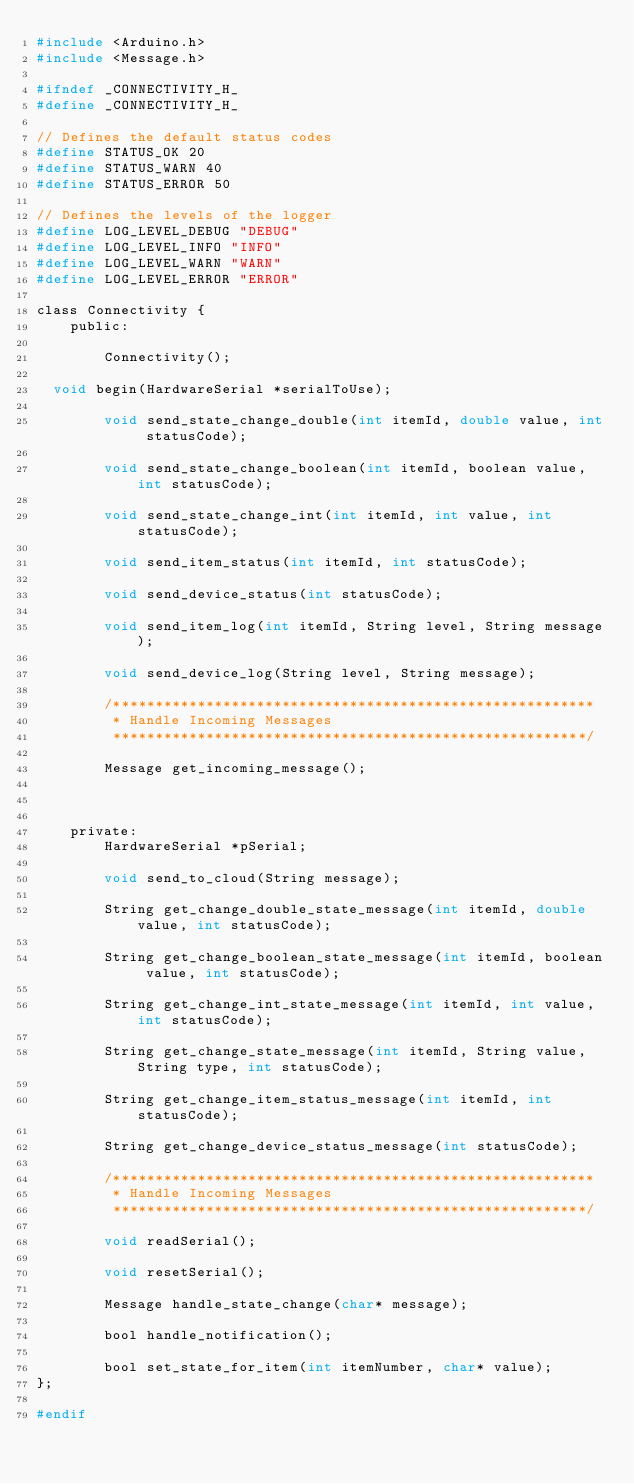<code> <loc_0><loc_0><loc_500><loc_500><_C_>#include <Arduino.h>
#include <Message.h>

#ifndef _CONNECTIVITY_H_
#define _CONNECTIVITY_H_

// Defines the default status codes
#define STATUS_OK 20
#define STATUS_WARN 40
#define STATUS_ERROR 50

// Defines the levels of the logger
#define LOG_LEVEL_DEBUG "DEBUG"
#define LOG_LEVEL_INFO "INFO"
#define LOG_LEVEL_WARN "WARN"
#define LOG_LEVEL_ERROR "ERROR"

class Connectivity {
    public:

        Connectivity();

	void begin(HardwareSerial *serialToUse);

        void send_state_change_double(int itemId, double value, int statusCode);

        void send_state_change_boolean(int itemId, boolean value, int statusCode);

        void send_state_change_int(int itemId, int value, int statusCode);

        void send_item_status(int itemId, int statusCode);

        void send_device_status(int statusCode);

        void send_item_log(int itemId, String level, String message);

        void send_device_log(String level, String message);

        /*********************************************************
         * Handle Incoming Messages
         ********************************************************/

        Message get_incoming_message();

        

    private:
        HardwareSerial *pSerial;

        void send_to_cloud(String message);

        String get_change_double_state_message(int itemId, double value, int statusCode);

        String get_change_boolean_state_message(int itemId, boolean value, int statusCode);

        String get_change_int_state_message(int itemId, int value, int statusCode);

        String get_change_state_message(int itemId, String value, String type, int statusCode);

        String get_change_item_status_message(int itemId, int statusCode);

        String get_change_device_status_message(int statusCode);

        /*********************************************************
         * Handle Incoming Messages
         ********************************************************/

        void readSerial();

        void resetSerial();

        Message handle_state_change(char* message);

        bool handle_notification();

        bool set_state_for_item(int itemNumber, char* value);
};

#endif
</code> 